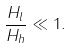Convert formula to latex. <formula><loc_0><loc_0><loc_500><loc_500>\frac { H _ { l } } { H _ { h } } \ll 1 .</formula> 